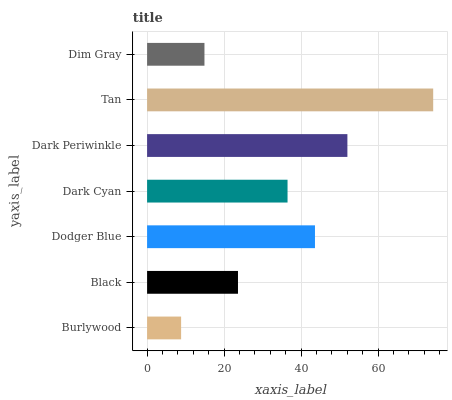Is Burlywood the minimum?
Answer yes or no. Yes. Is Tan the maximum?
Answer yes or no. Yes. Is Black the minimum?
Answer yes or no. No. Is Black the maximum?
Answer yes or no. No. Is Black greater than Burlywood?
Answer yes or no. Yes. Is Burlywood less than Black?
Answer yes or no. Yes. Is Burlywood greater than Black?
Answer yes or no. No. Is Black less than Burlywood?
Answer yes or no. No. Is Dark Cyan the high median?
Answer yes or no. Yes. Is Dark Cyan the low median?
Answer yes or no. Yes. Is Black the high median?
Answer yes or no. No. Is Black the low median?
Answer yes or no. No. 